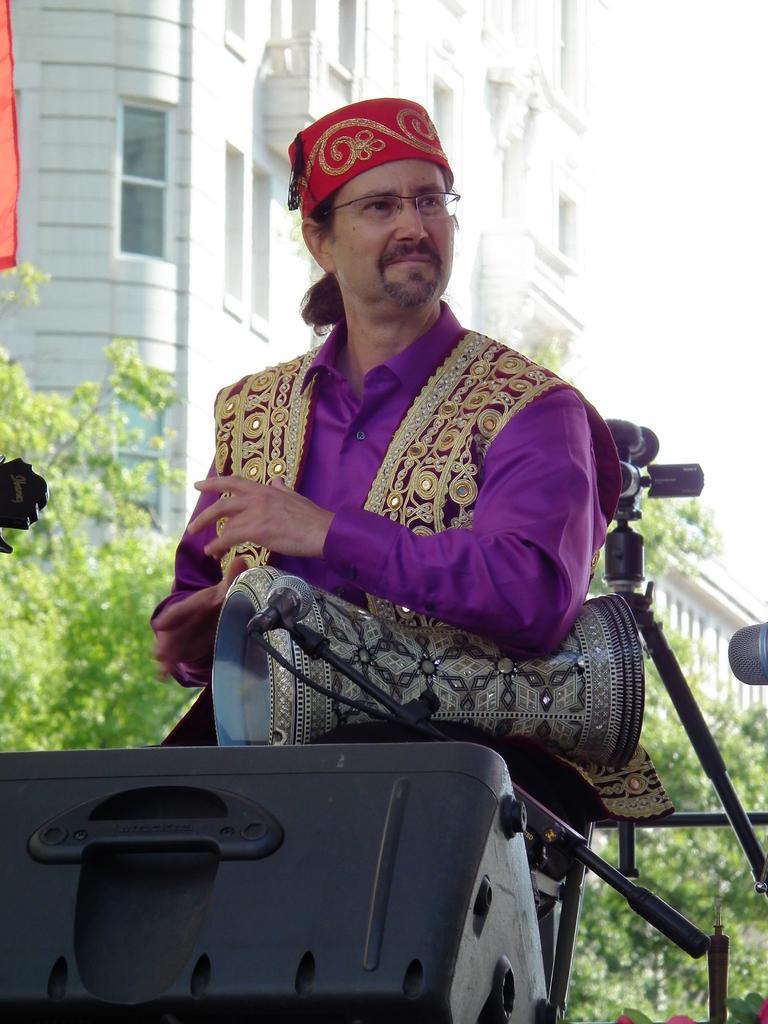Could you give a brief overview of what you see in this image? In this image we can see a man and a musical instrument. In front of him we can see a mic with a stand. Behind the person we can see a camera with stand, trees and a building. At the bottom we can see a black object. 